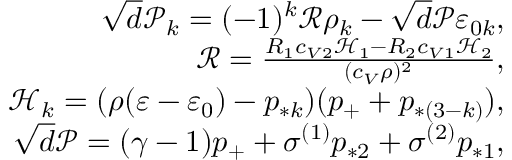<formula> <loc_0><loc_0><loc_500><loc_500>\begin{array} { r } { \sqrt { d } \mathcal { P } _ { k } = ( - 1 ) ^ { k } \mathcal { R } \rho _ { k } - \sqrt { d } \mathcal { P } \varepsilon _ { 0 k } , } \\ { \mathcal { R } = \frac { R _ { 1 } c _ { V 2 } \mathcal { H } _ { 1 } - R _ { 2 } c _ { V 1 } \mathcal { H } _ { 2 } } { ( c _ { V } \rho ) ^ { 2 } } , } \\ { \mathcal { H } _ { k } = ( \rho ( \varepsilon - \varepsilon _ { 0 } ) - p _ { * k } ) ( p _ { + } + p _ { * ( 3 - k ) } ) , } \\ { \sqrt { d } \mathcal { P } = ( \gamma - 1 ) p _ { + } + \sigma ^ { ( 1 ) } p _ { * 2 } + \sigma ^ { ( 2 ) } p _ { * 1 } , } \end{array}</formula> 